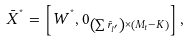<formula> <loc_0><loc_0><loc_500><loc_500>{ { \bar { X } } ^ { ^ { * } } } = \left [ { { { W } ^ { ^ { * } } } , { { 0 } _ { \left ( { \sum { { { \bar { r } } _ { l ^ { \prime } } } } } \right ) \times \left ( { { M _ { t } } - K } \right ) } } } \right ] ,</formula> 